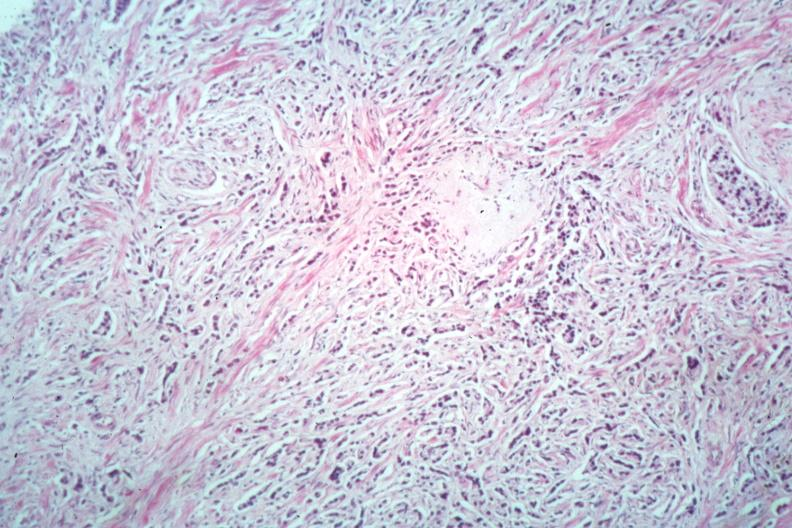does this image show diffusely infiltrating small cell carcinoma readily seen?
Answer the question using a single word or phrase. Yes 